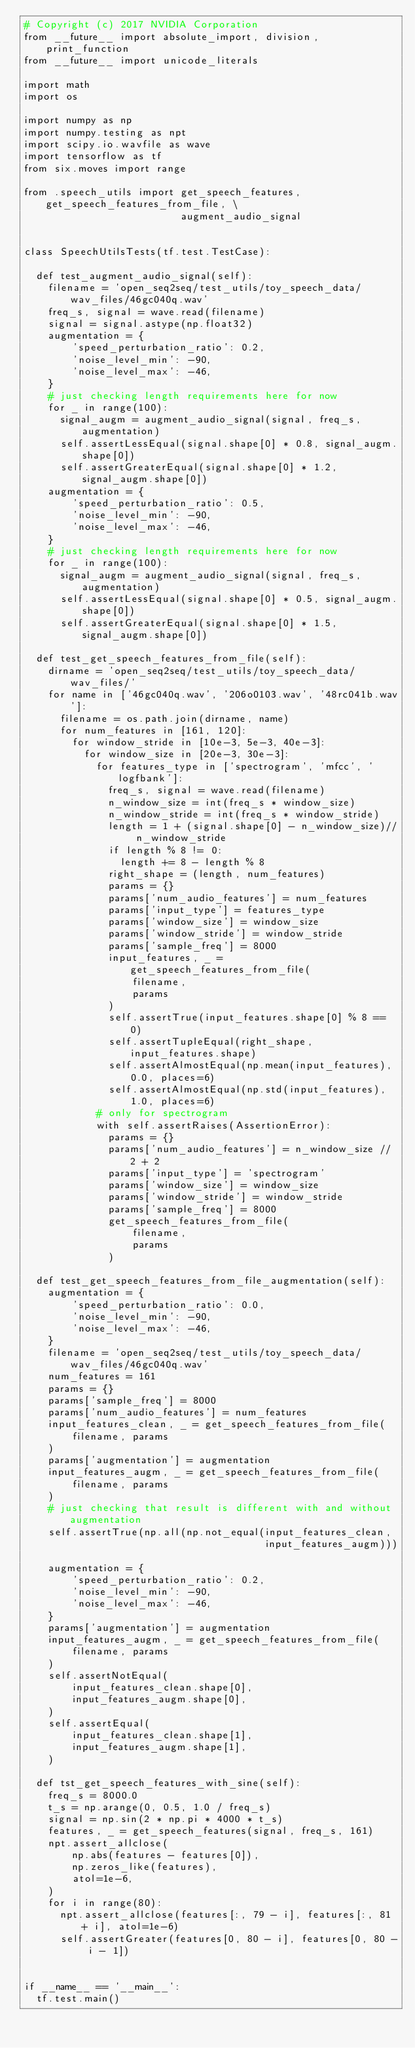<code> <loc_0><loc_0><loc_500><loc_500><_Python_># Copyright (c) 2017 NVIDIA Corporation
from __future__ import absolute_import, division, print_function
from __future__ import unicode_literals

import math
import os

import numpy as np
import numpy.testing as npt
import scipy.io.wavfile as wave
import tensorflow as tf
from six.moves import range

from .speech_utils import get_speech_features, get_speech_features_from_file, \
                          augment_audio_signal


class SpeechUtilsTests(tf.test.TestCase):

  def test_augment_audio_signal(self):
    filename = 'open_seq2seq/test_utils/toy_speech_data/wav_files/46gc040q.wav'
    freq_s, signal = wave.read(filename)
    signal = signal.astype(np.float32)
    augmentation = {
        'speed_perturbation_ratio': 0.2,
        'noise_level_min': -90,
        'noise_level_max': -46,
    }
    # just checking length requirements here for now
    for _ in range(100):
      signal_augm = augment_audio_signal(signal, freq_s, augmentation)
      self.assertLessEqual(signal.shape[0] * 0.8, signal_augm.shape[0])
      self.assertGreaterEqual(signal.shape[0] * 1.2, signal_augm.shape[0])
    augmentation = {
        'speed_perturbation_ratio': 0.5,
        'noise_level_min': -90,
        'noise_level_max': -46,
    }
    # just checking length requirements here for now
    for _ in range(100):
      signal_augm = augment_audio_signal(signal, freq_s, augmentation)
      self.assertLessEqual(signal.shape[0] * 0.5, signal_augm.shape[0])
      self.assertGreaterEqual(signal.shape[0] * 1.5, signal_augm.shape[0])

  def test_get_speech_features_from_file(self):
    dirname = 'open_seq2seq/test_utils/toy_speech_data/wav_files/'
    for name in ['46gc040q.wav', '206o0103.wav', '48rc041b.wav']:
      filename = os.path.join(dirname, name)
      for num_features in [161, 120]:
        for window_stride in [10e-3, 5e-3, 40e-3]:
          for window_size in [20e-3, 30e-3]:
            for features_type in ['spectrogram', 'mfcc', 'logfbank']:
              freq_s, signal = wave.read(filename)
              n_window_size = int(freq_s * window_size)
              n_window_stride = int(freq_s * window_stride)
              length = 1 + (signal.shape[0] - n_window_size)// n_window_stride
              if length % 8 != 0:
                length += 8 - length % 8
              right_shape = (length, num_features)
              params = {}
              params['num_audio_features'] = num_features
              params['input_type'] = features_type
              params['window_size'] = window_size
              params['window_stride'] = window_stride
              params['sample_freq'] = 8000
              input_features, _ = get_speech_features_from_file(
                  filename,
                  params
              )
              self.assertTrue(input_features.shape[0] % 8 == 0)
              self.assertTupleEqual(right_shape, input_features.shape)
              self.assertAlmostEqual(np.mean(input_features), 0.0, places=6)
              self.assertAlmostEqual(np.std(input_features), 1.0, places=6)
            # only for spectrogram
            with self.assertRaises(AssertionError):
              params = {}
              params['num_audio_features'] = n_window_size // 2 + 2
              params['input_type'] = 'spectrogram'
              params['window_size'] = window_size
              params['window_stride'] = window_stride
              params['sample_freq'] = 8000
              get_speech_features_from_file(
                  filename,
                  params
              )

  def test_get_speech_features_from_file_augmentation(self):
    augmentation = {
        'speed_perturbation_ratio': 0.0,
        'noise_level_min': -90,
        'noise_level_max': -46,
    }
    filename = 'open_seq2seq/test_utils/toy_speech_data/wav_files/46gc040q.wav'
    num_features = 161
    params = {}
    params['sample_freq'] = 8000
    params['num_audio_features'] = num_features
    input_features_clean, _ = get_speech_features_from_file(
        filename, params
    )
    params['augmentation'] = augmentation
    input_features_augm, _ = get_speech_features_from_file(
        filename, params
    )
    # just checking that result is different with and without augmentation
    self.assertTrue(np.all(np.not_equal(input_features_clean,
                                        input_features_augm)))

    augmentation = {
        'speed_perturbation_ratio': 0.2,
        'noise_level_min': -90,
        'noise_level_max': -46,
    }
    params['augmentation'] = augmentation
    input_features_augm, _ = get_speech_features_from_file(
        filename, params
    )
    self.assertNotEqual(
        input_features_clean.shape[0],
        input_features_augm.shape[0],
    )
    self.assertEqual(
        input_features_clean.shape[1],
        input_features_augm.shape[1],
    )

  def tst_get_speech_features_with_sine(self):
    freq_s = 8000.0
    t_s = np.arange(0, 0.5, 1.0 / freq_s)
    signal = np.sin(2 * np.pi * 4000 * t_s)
    features, _ = get_speech_features(signal, freq_s, 161)
    npt.assert_allclose(
        np.abs(features - features[0]),
        np.zeros_like(features),
        atol=1e-6,
    )
    for i in range(80):
      npt.assert_allclose(features[:, 79 - i], features[:, 81 + i], atol=1e-6)
      self.assertGreater(features[0, 80 - i], features[0, 80 - i - 1])


if __name__ == '__main__':
  tf.test.main()
</code> 